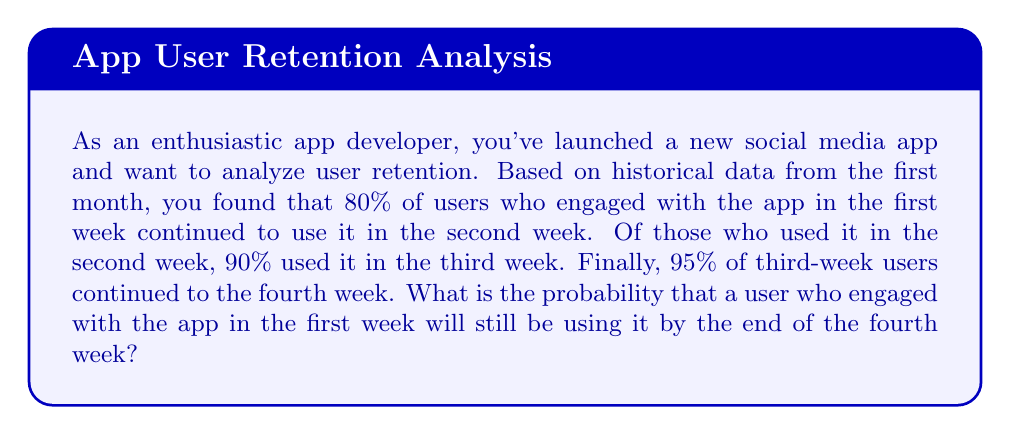Can you solve this math problem? To solve this problem, we need to use the concept of conditional probability. We'll calculate the probability of a user continuing to use the app through each week, then multiply these probabilities together to find the overall retention probability.

Let's define the events:
$W_1$ = User engages in Week 1
$W_2$ = User engages in Week 2
$W_3$ = User engages in Week 3
$W_4$ = User engages in Week 4

Given probabilities:
$P(W_2|W_1) = 0.80$
$P(W_3|W_2) = 0.90$
$P(W_4|W_3) = 0.95$

We want to find $P(W_4|W_1)$, which can be calculated using the chain rule of probability:

$$P(W_4|W_1) = P(W_2|W_1) \times P(W_3|W_2) \times P(W_4|W_3)$$

Substituting the given probabilities:

$$P(W_4|W_1) = 0.80 \times 0.90 \times 0.95$$

Calculating:

$$P(W_4|W_1) = 0.684$$

Therefore, the probability that a user who engaged with the app in the first week will still be using it by the end of the fourth week is 0.684 or 68.4%.
Answer: $0.684$ or $68.4\%$ 